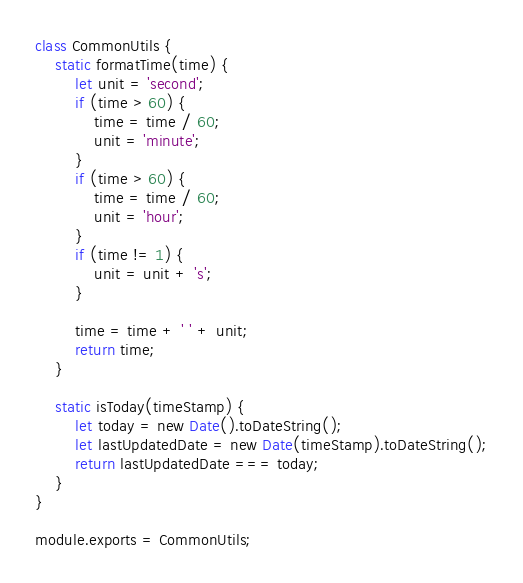Convert code to text. <code><loc_0><loc_0><loc_500><loc_500><_JavaScript_>class CommonUtils {
    static formatTime(time) {
        let unit = 'second';
        if (time > 60) {
            time = time / 60;
            unit = 'minute';
        }
        if (time > 60) {
            time = time / 60;
            unit = 'hour';
        }
        if (time != 1) {
            unit = unit + 's';
        }

        time = time + ' ' + unit;
        return time;
    }

    static isToday(timeStamp) {
        let today = new Date().toDateString();
        let lastUpdatedDate = new Date(timeStamp).toDateString();
        return lastUpdatedDate === today;
    }
}

module.exports = CommonUtils;</code> 